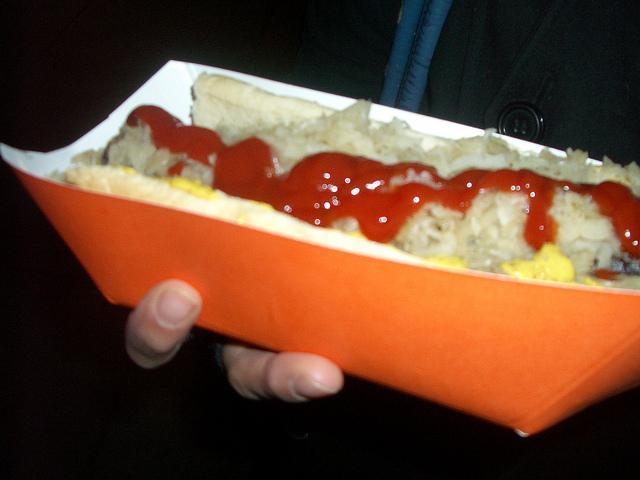How many of the person's fingers are visible?
Give a very brief answer. 2. How many dogs are looking at the camers?
Give a very brief answer. 0. 